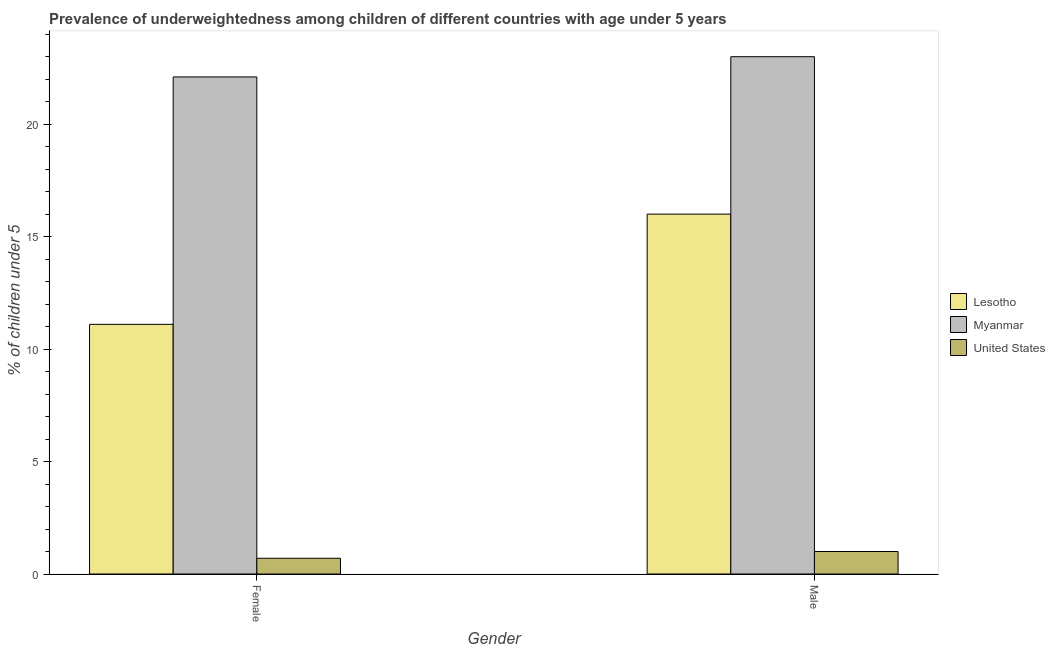How many different coloured bars are there?
Make the answer very short. 3. Are the number of bars per tick equal to the number of legend labels?
Ensure brevity in your answer.  Yes. Are the number of bars on each tick of the X-axis equal?
Keep it short and to the point. Yes. What is the label of the 1st group of bars from the left?
Provide a short and direct response. Female. What is the percentage of underweighted female children in Lesotho?
Give a very brief answer. 11.1. In which country was the percentage of underweighted male children maximum?
Offer a terse response. Myanmar. What is the total percentage of underweighted female children in the graph?
Your response must be concise. 33.9. What is the difference between the percentage of underweighted male children in Myanmar and the percentage of underweighted female children in United States?
Keep it short and to the point. 22.3. What is the average percentage of underweighted male children per country?
Your answer should be very brief. 13.33. What is the difference between the percentage of underweighted male children and percentage of underweighted female children in Lesotho?
Give a very brief answer. 4.9. In how many countries, is the percentage of underweighted male children greater than 2 %?
Ensure brevity in your answer.  2. What is the ratio of the percentage of underweighted female children in Myanmar to that in United States?
Offer a terse response. 31.57. Is the percentage of underweighted male children in Myanmar less than that in Lesotho?
Give a very brief answer. No. What does the 3rd bar from the left in Female represents?
Your response must be concise. United States. What does the 2nd bar from the right in Female represents?
Your response must be concise. Myanmar. Are all the bars in the graph horizontal?
Keep it short and to the point. No. What is the difference between two consecutive major ticks on the Y-axis?
Keep it short and to the point. 5. Are the values on the major ticks of Y-axis written in scientific E-notation?
Give a very brief answer. No. Does the graph contain grids?
Provide a succinct answer. No. What is the title of the graph?
Your response must be concise. Prevalence of underweightedness among children of different countries with age under 5 years. What is the label or title of the Y-axis?
Keep it short and to the point.  % of children under 5. What is the  % of children under 5 in Lesotho in Female?
Offer a very short reply. 11.1. What is the  % of children under 5 in Myanmar in Female?
Your response must be concise. 22.1. What is the  % of children under 5 in United States in Female?
Give a very brief answer. 0.7. What is the  % of children under 5 of Myanmar in Male?
Keep it short and to the point. 23. What is the  % of children under 5 in United States in Male?
Offer a terse response. 1. Across all Gender, what is the maximum  % of children under 5 in Lesotho?
Provide a succinct answer. 16. Across all Gender, what is the maximum  % of children under 5 of United States?
Ensure brevity in your answer.  1. Across all Gender, what is the minimum  % of children under 5 in Lesotho?
Provide a succinct answer. 11.1. Across all Gender, what is the minimum  % of children under 5 in Myanmar?
Keep it short and to the point. 22.1. Across all Gender, what is the minimum  % of children under 5 of United States?
Give a very brief answer. 0.7. What is the total  % of children under 5 in Lesotho in the graph?
Keep it short and to the point. 27.1. What is the total  % of children under 5 in Myanmar in the graph?
Offer a terse response. 45.1. What is the difference between the  % of children under 5 of Lesotho in Female and the  % of children under 5 of Myanmar in Male?
Provide a succinct answer. -11.9. What is the difference between the  % of children under 5 of Lesotho in Female and the  % of children under 5 of United States in Male?
Offer a very short reply. 10.1. What is the difference between the  % of children under 5 of Myanmar in Female and the  % of children under 5 of United States in Male?
Your answer should be compact. 21.1. What is the average  % of children under 5 in Lesotho per Gender?
Provide a short and direct response. 13.55. What is the average  % of children under 5 of Myanmar per Gender?
Your answer should be very brief. 22.55. What is the difference between the  % of children under 5 in Lesotho and  % of children under 5 in Myanmar in Female?
Keep it short and to the point. -11. What is the difference between the  % of children under 5 of Myanmar and  % of children under 5 of United States in Female?
Offer a very short reply. 21.4. What is the difference between the  % of children under 5 in Lesotho and  % of children under 5 in Myanmar in Male?
Provide a succinct answer. -7. What is the difference between the  % of children under 5 of Lesotho and  % of children under 5 of United States in Male?
Ensure brevity in your answer.  15. What is the difference between the  % of children under 5 of Myanmar and  % of children under 5 of United States in Male?
Offer a terse response. 22. What is the ratio of the  % of children under 5 in Lesotho in Female to that in Male?
Provide a succinct answer. 0.69. What is the ratio of the  % of children under 5 in Myanmar in Female to that in Male?
Your answer should be compact. 0.96. What is the difference between the highest and the second highest  % of children under 5 in Lesotho?
Make the answer very short. 4.9. What is the difference between the highest and the lowest  % of children under 5 of United States?
Ensure brevity in your answer.  0.3. 